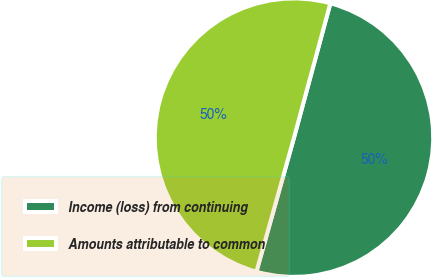Convert chart. <chart><loc_0><loc_0><loc_500><loc_500><pie_chart><fcel>Income (loss) from continuing<fcel>Amounts attributable to common<nl><fcel>50.14%<fcel>49.86%<nl></chart> 